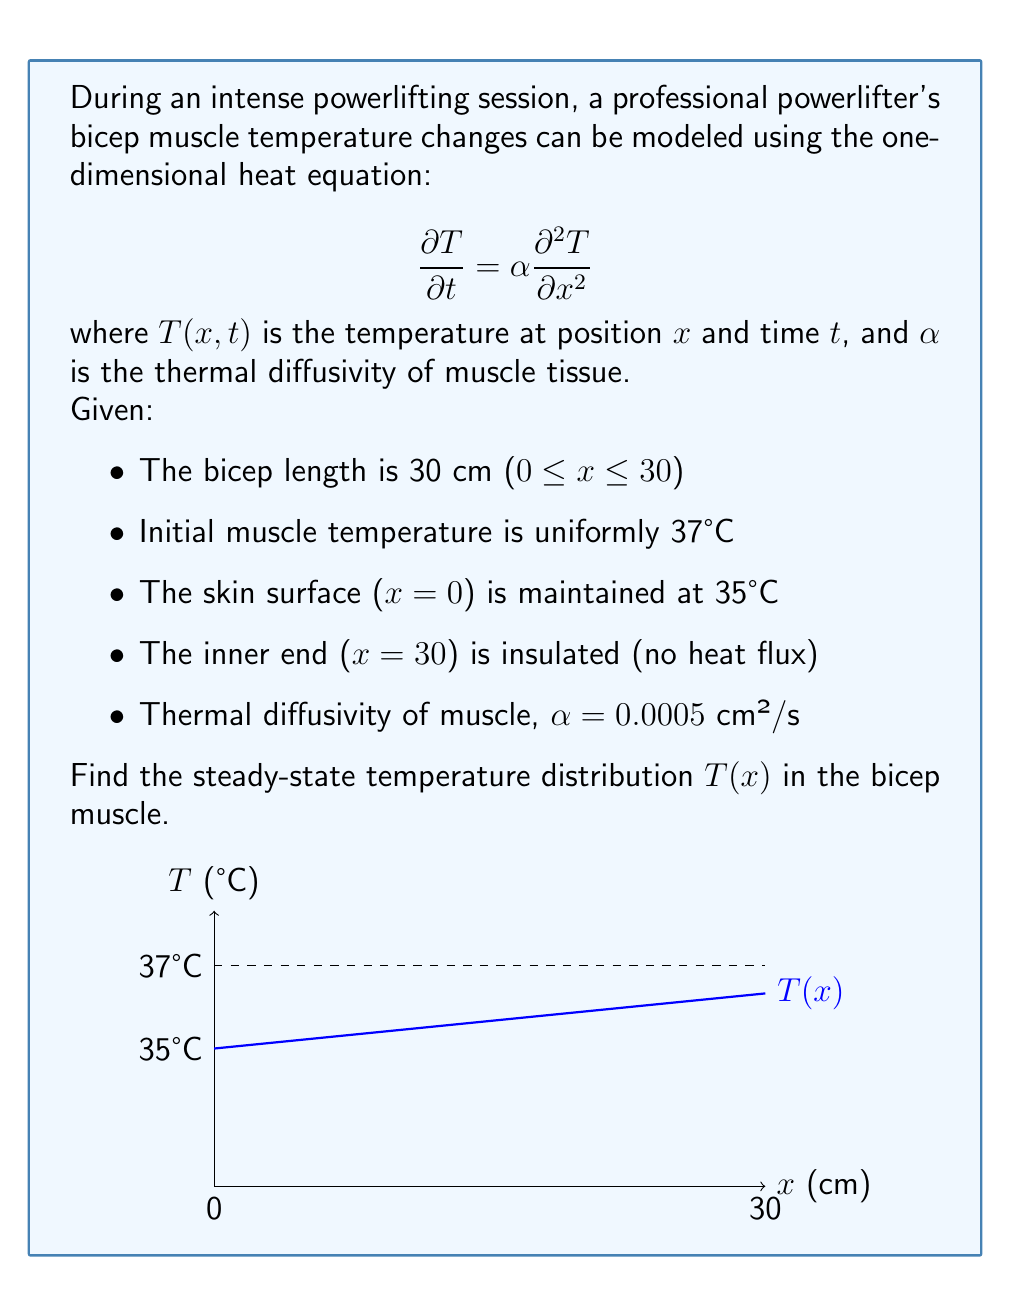Teach me how to tackle this problem. To solve this problem, we'll follow these steps:

1) For the steady-state solution, $\frac{\partial T}{\partial t} = 0$, so the heat equation reduces to:

   $$0 = \alpha \frac{d^2 T}{dx^2}$$

2) Integrating twice:

   $$T(x) = Ax + B$$

   where A and B are constants to be determined from the boundary conditions.

3) Apply the boundary conditions:
   
   At x = 0: T(0) = 35°C, so B = 35
   
   At x = 30: $\frac{dT}{dx} = 0$ (insulated end), so A = 0

4) Therefore, the steady-state solution is:

   $$T(x) = 35$$

This means that at steady-state, the temperature throughout the muscle will be uniform and equal to the skin surface temperature.

5) We can verify this makes sense physically:
   - With no internal heat generation and an insulated end, heat will flow from the warmer interior to the cooler surface until equilibrium is reached.
   - At equilibrium, there's no temperature gradient, so the entire muscle is at the same temperature as the skin surface.
Answer: T(x) = 35°C 